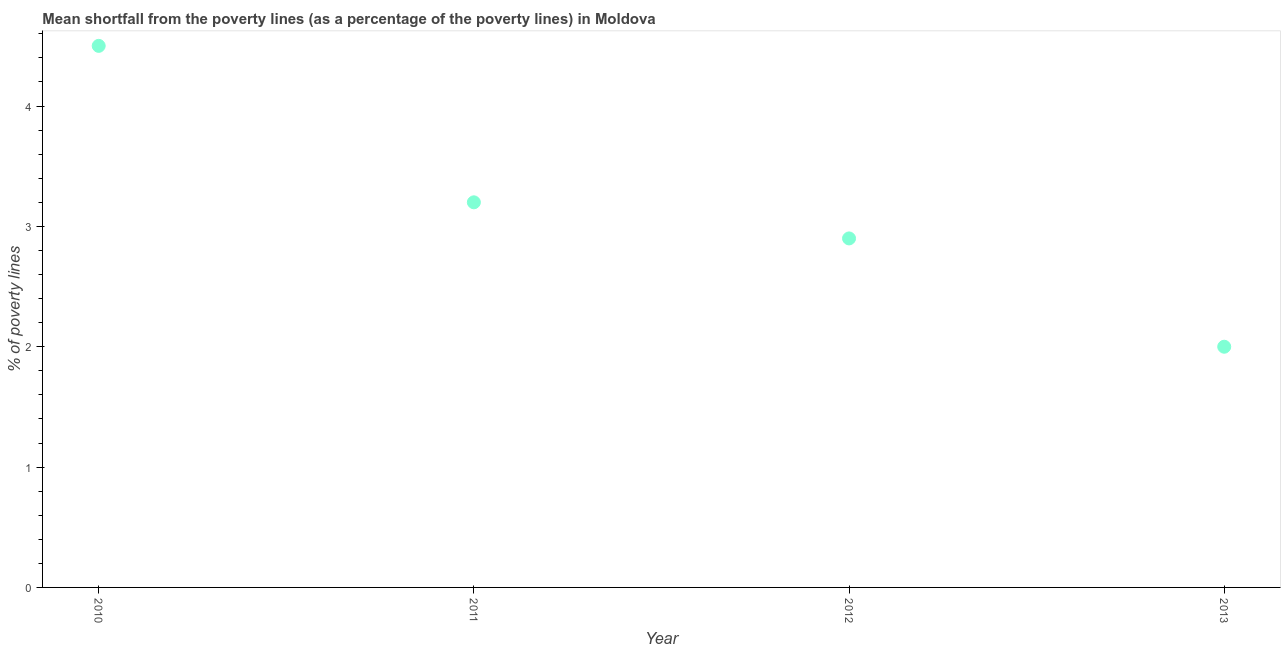What is the poverty gap at national poverty lines in 2011?
Give a very brief answer. 3.2. In which year was the poverty gap at national poverty lines maximum?
Provide a short and direct response. 2010. What is the difference between the poverty gap at national poverty lines in 2010 and 2012?
Your answer should be very brief. 1.6. What is the average poverty gap at national poverty lines per year?
Offer a very short reply. 3.15. What is the median poverty gap at national poverty lines?
Offer a very short reply. 3.05. In how many years, is the poverty gap at national poverty lines greater than 1.2 %?
Your answer should be compact. 4. What is the ratio of the poverty gap at national poverty lines in 2012 to that in 2013?
Offer a terse response. 1.45. Is the poverty gap at national poverty lines in 2011 less than that in 2012?
Provide a succinct answer. No. Is the difference between the poverty gap at national poverty lines in 2010 and 2013 greater than the difference between any two years?
Make the answer very short. Yes. What is the difference between the highest and the second highest poverty gap at national poverty lines?
Keep it short and to the point. 1.3. Is the sum of the poverty gap at national poverty lines in 2010 and 2013 greater than the maximum poverty gap at national poverty lines across all years?
Provide a succinct answer. Yes. Are the values on the major ticks of Y-axis written in scientific E-notation?
Keep it short and to the point. No. Does the graph contain grids?
Offer a terse response. No. What is the title of the graph?
Your answer should be compact. Mean shortfall from the poverty lines (as a percentage of the poverty lines) in Moldova. What is the label or title of the Y-axis?
Provide a short and direct response. % of poverty lines. What is the % of poverty lines in 2011?
Offer a terse response. 3.2. What is the difference between the % of poverty lines in 2010 and 2012?
Provide a succinct answer. 1.6. What is the difference between the % of poverty lines in 2010 and 2013?
Provide a short and direct response. 2.5. What is the difference between the % of poverty lines in 2011 and 2012?
Offer a terse response. 0.3. What is the difference between the % of poverty lines in 2012 and 2013?
Your answer should be compact. 0.9. What is the ratio of the % of poverty lines in 2010 to that in 2011?
Offer a terse response. 1.41. What is the ratio of the % of poverty lines in 2010 to that in 2012?
Make the answer very short. 1.55. What is the ratio of the % of poverty lines in 2010 to that in 2013?
Offer a terse response. 2.25. What is the ratio of the % of poverty lines in 2011 to that in 2012?
Provide a succinct answer. 1.1. What is the ratio of the % of poverty lines in 2012 to that in 2013?
Offer a terse response. 1.45. 